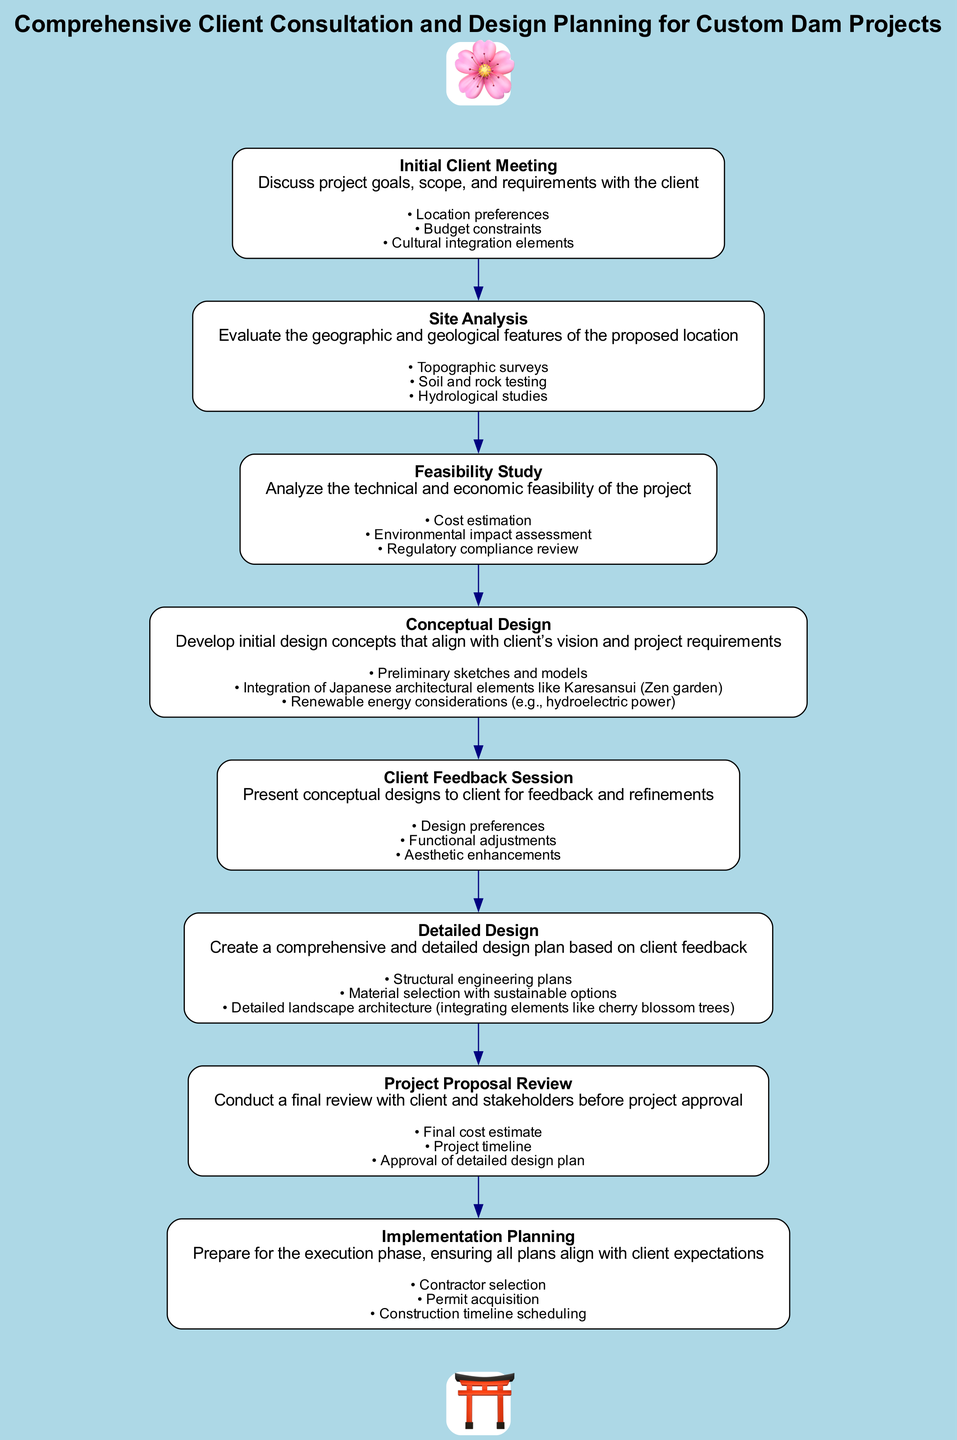What is the first step in the diagram? The diagram starts with "Initial Client Meeting," which is the first node presented in the flowchart.
Answer: Initial Client Meeting How many steps are in the flowchart? The diagram includes a total of eight steps, starting from the initial client meeting and ending with implementation planning.
Answer: Eight What is the last step listed in the flowchart? The last step in the flowchart is "Implementation Planning," which signifies the preparation for the execution phase.
Answer: Implementation Planning Which step involves evaluating geographic and geological features? The step that focuses on evaluating geographic and geological features is "Site Analysis," which is the second step in the flowchart.
Answer: Site Analysis What type of design is developed in the fourth step? The fourth step, "Conceptual Design," involves developing initial design concepts that align with the client’s vision.
Answer: Conceptual Design Which steps include client interaction? The steps that include client interaction are "Initial Client Meeting," "Client Feedback Session," and "Project Proposal Review," as they all require client input or reviews.
Answer: Initial Client Meeting, Client Feedback Session, Project Proposal Review What is analyzed in the feasibility study? The "Feasibility Study" analyzes the technical and economic feasibility of the project, including cost estimation and environmental impact assessments.
Answer: Technical and economic feasibility What unique architectural element is integrated during conceptual design? The "Conceptual Design" step integrates Japanese architectural elements, specifically mentioning Karesansui, which is a Zen garden.
Answer: Karesansui How does the diagram represent Japanese culture? The diagram features decorative elements like cherry blossoms and a torii gate, which are symbols of Japanese culture, enhancing the thematic integration in the flowchart.
Answer: Cherry blossoms and torii gate 